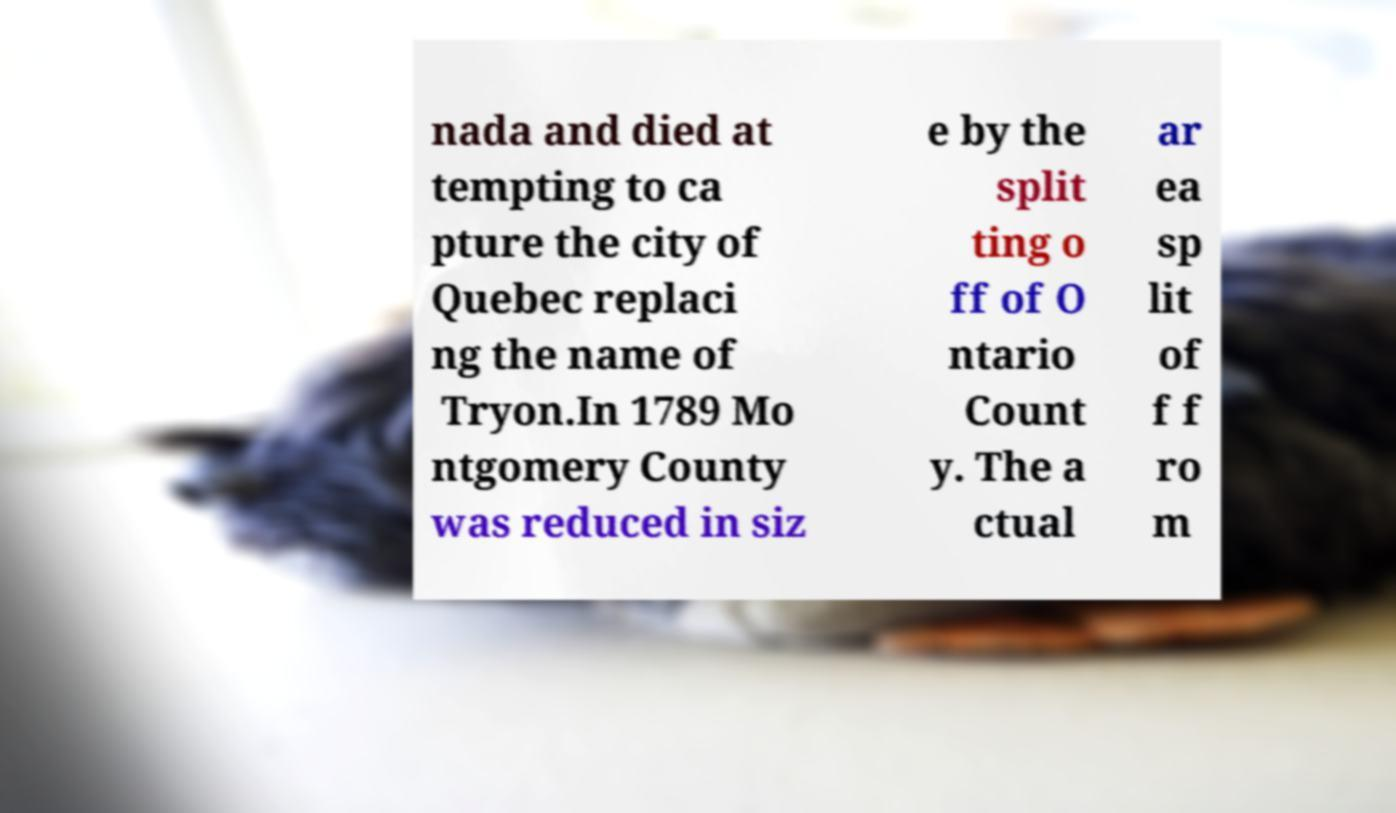Can you read and provide the text displayed in the image?This photo seems to have some interesting text. Can you extract and type it out for me? nada and died at tempting to ca pture the city of Quebec replaci ng the name of Tryon.In 1789 Mo ntgomery County was reduced in siz e by the split ting o ff of O ntario Count y. The a ctual ar ea sp lit of f f ro m 